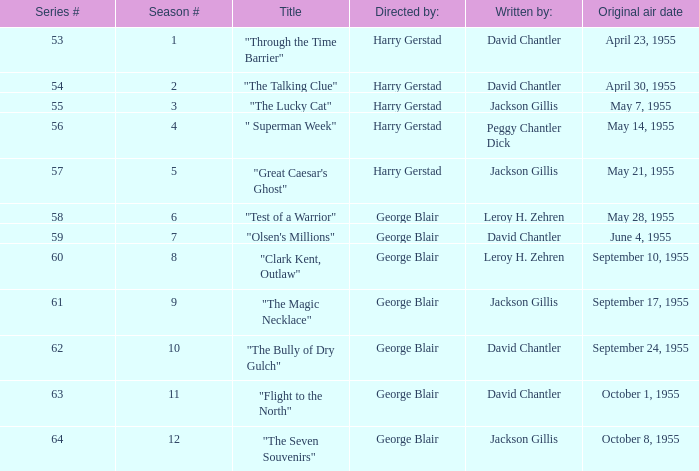When did season 9 originally air? September 17, 1955. 